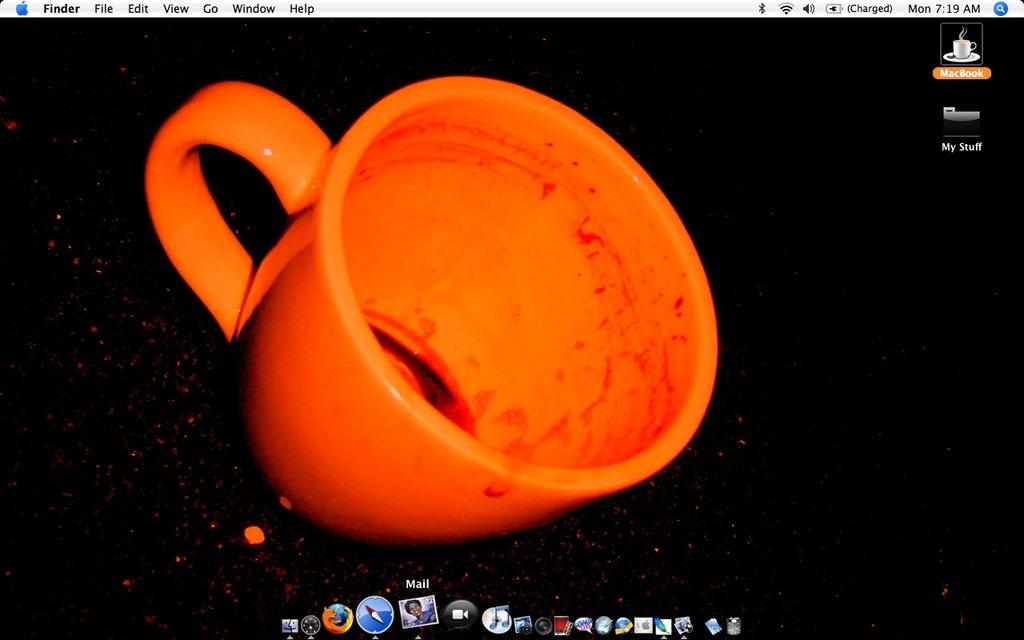What is the main object on the desk in the image? There is a monitor screen in the image. What else can be seen on the desk? There is a used cup on a table in the image. What is displayed on the monitor screen? There are visible applications on the monitor screen. What additional information is visible in the image? The time and day are visible in the image. Can you see a goldfish swimming in the cup in the image? There is no goldfish present in the image; the cup is used but empty. What type of shoe is visible on the monitor screen in the image? There is no shoe visible on the monitor screen or in the image. 